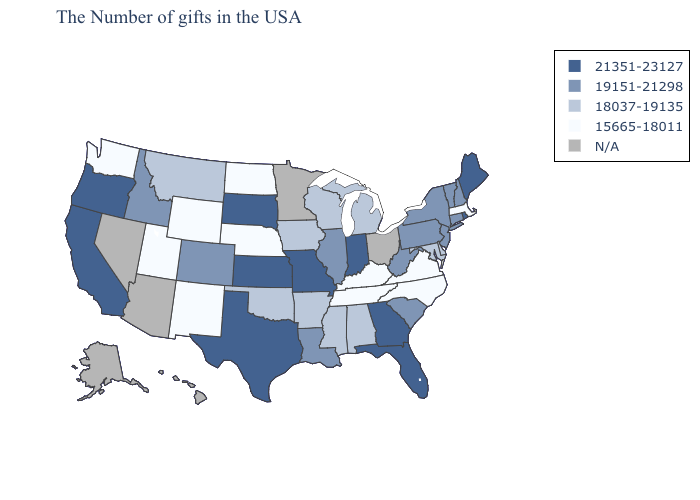Name the states that have a value in the range 21351-23127?
Concise answer only. Maine, Rhode Island, Florida, Georgia, Indiana, Missouri, Kansas, Texas, South Dakota, California, Oregon. Name the states that have a value in the range N/A?
Quick response, please. Ohio, Minnesota, Arizona, Nevada, Alaska, Hawaii. Name the states that have a value in the range 19151-21298?
Answer briefly. New Hampshire, Vermont, Connecticut, New York, New Jersey, Pennsylvania, South Carolina, West Virginia, Illinois, Louisiana, Colorado, Idaho. What is the highest value in the USA?
Short answer required. 21351-23127. Among the states that border Maryland , which have the lowest value?
Concise answer only. Virginia. Does Vermont have the lowest value in the Northeast?
Answer briefly. No. What is the lowest value in the USA?
Give a very brief answer. 15665-18011. Does the map have missing data?
Be succinct. Yes. Name the states that have a value in the range 19151-21298?
Concise answer only. New Hampshire, Vermont, Connecticut, New York, New Jersey, Pennsylvania, South Carolina, West Virginia, Illinois, Louisiana, Colorado, Idaho. Name the states that have a value in the range 15665-18011?
Give a very brief answer. Massachusetts, Virginia, North Carolina, Kentucky, Tennessee, Nebraska, North Dakota, Wyoming, New Mexico, Utah, Washington. What is the highest value in the USA?
Give a very brief answer. 21351-23127. Among the states that border Missouri , which have the highest value?
Give a very brief answer. Kansas. What is the value of Delaware?
Keep it brief. 18037-19135. Name the states that have a value in the range 19151-21298?
Concise answer only. New Hampshire, Vermont, Connecticut, New York, New Jersey, Pennsylvania, South Carolina, West Virginia, Illinois, Louisiana, Colorado, Idaho. 